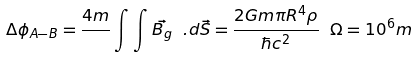<formula> <loc_0><loc_0><loc_500><loc_500>\Delta { \phi } _ { A - B } = \frac { 4 m } { } \int \int \vec { B _ { g } } \ . d \vec { S } = \frac { 2 G m \pi R ^ { 4 } \rho } { \hbar { c } ^ { 2 } } \ \Omega = 1 0 ^ { 6 } m</formula> 